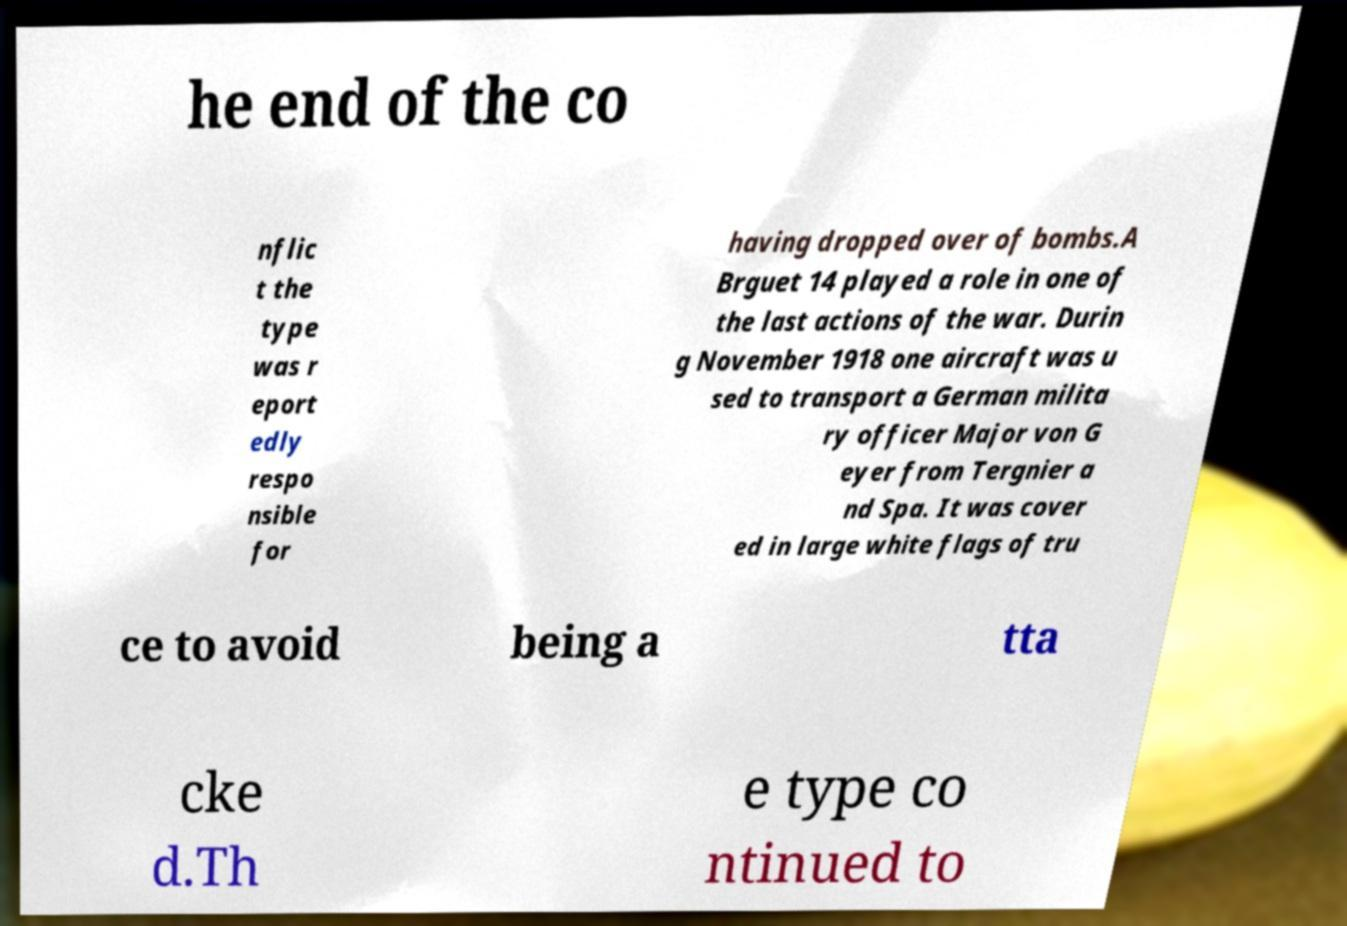Could you assist in decoding the text presented in this image and type it out clearly? he end of the co nflic t the type was r eport edly respo nsible for having dropped over of bombs.A Brguet 14 played a role in one of the last actions of the war. Durin g November 1918 one aircraft was u sed to transport a German milita ry officer Major von G eyer from Tergnier a nd Spa. It was cover ed in large white flags of tru ce to avoid being a tta cke d.Th e type co ntinued to 